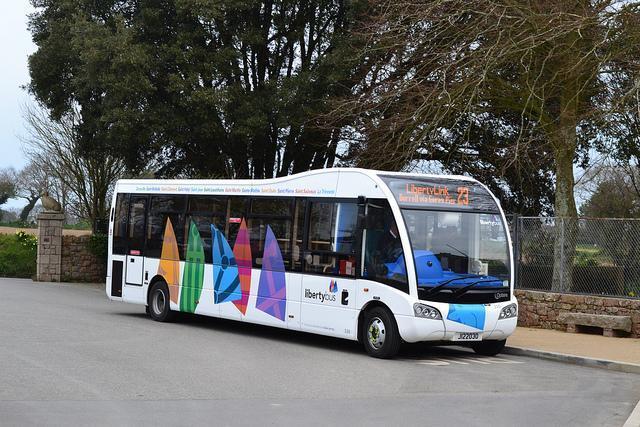How many different colors are on the side of the bus?
Give a very brief answer. 5. How many elephants are walking in the picture?
Give a very brief answer. 0. 